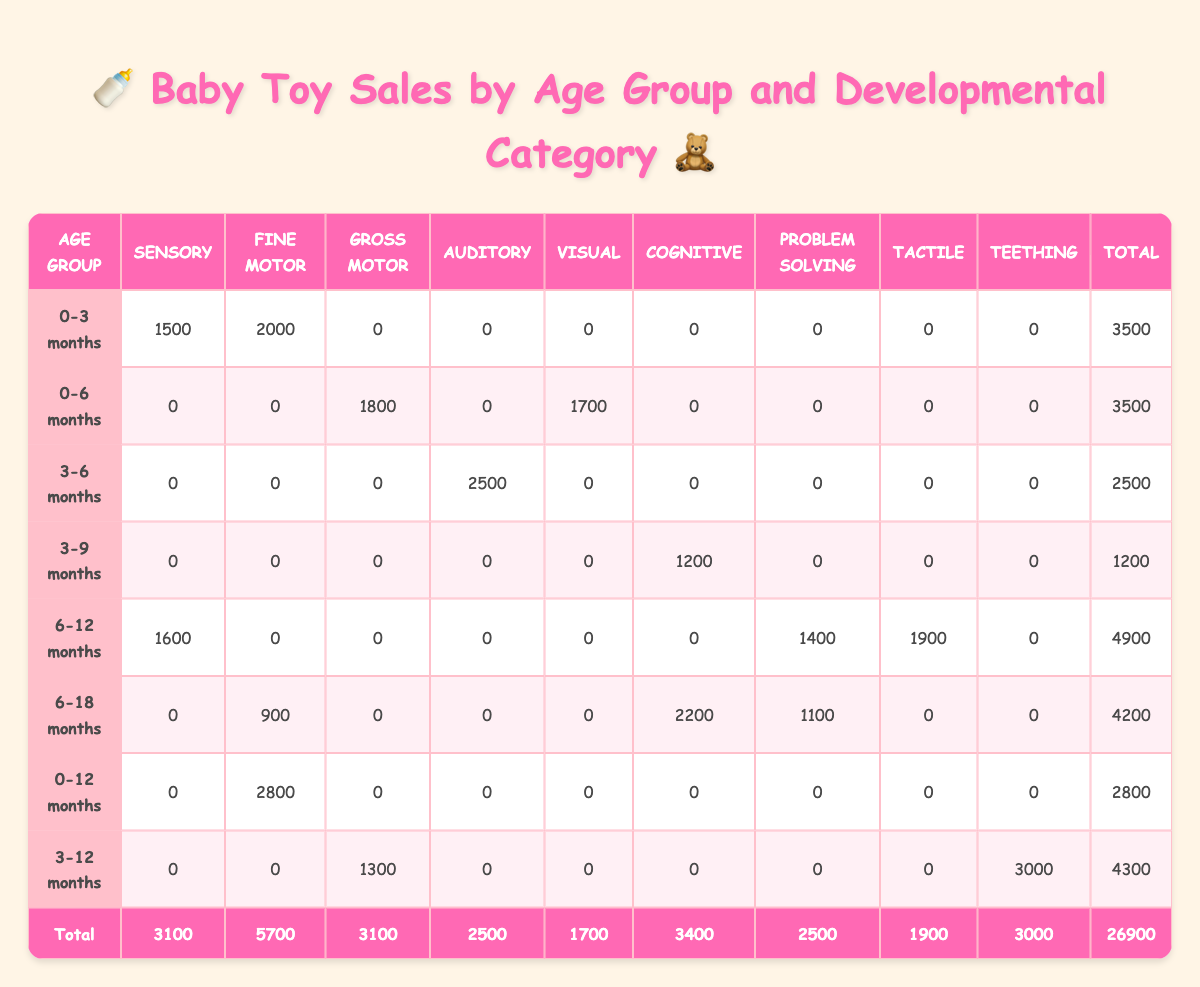What is the total sales quantity for toys designed for the age group 0-3 months? From the table, the sales quantity for the age group 0-3 months is listed as 1500 for Sensory and 2000 for Fine Motor toys. Summing these gives 1500 + 2000 = 3500.
Answer: 3500 Which age group has the highest sales quantity for Auditory toys? Referring to the table, only the age group 3-6 months has sales quantity for Auditory toys, which is 2500. Other age groups do not have any sales for this category, making this the highest.
Answer: 3-6 months Is there any age group that has sales for Teething toys? Checking the table reveals that only the age group 3-12 months has a sales quantity for Teething toys listed as 3000. Therefore, there is one age group with sales for this category.
Answer: Yes What developmental category has the highest total sales across all age groups? By examining the total sales for each category, we see Sensory has 3100, Fine Motor has 5700, Gross Motor has 3100, Auditory has 2500, Visual has 1700, Cognitive has 3400, Problem Solving has 2500, Tactile has 1900, and Teething has 3000. The highest is Fine Motor with 5700.
Answer: Fine Motor What is the average sales quantity for toys in the age group 6-12 months? The sales quantities for the 6-12 months age group are 1600 (Sensory), 0 (Fine Motor), 0 (Gross Motor), 0 (Auditory), 0 (Visual), 0 (Cognitive), 1400 (Problem Solving), 1900 (Tactile), and 0 (Teething), which gives a total of 4900. With 8 entries, the average is 4900 / 8 = 612.5.
Answer: 612.5 Which category has the lowest sales quantity? Looking at the total sales for each category, the lowest figure is for Visual toys at 1700. All other categories have higher totals.
Answer: Visual If we compare the sales of Cognitive toys between the age groups 3-9 months and 6-18 months, which one has a higher quantity? The sales quantity for Cognitive toys is 1200 for the 3-9 months age group and 2200 for the 6-18 months age group. Therefore, 6-18 months has the higher quantity.
Answer: 6-18 months What is the total sales of toys in the age group 3-12 months? The sales quantities for this age group are 1300 (Gross Motor), 0 (Fine Motor), 0 (Auditory), 0 (Visual), 0 (Cognitive), 0 (Problem Solving), 0 (Tactile), and 3000 (Teething), summing them gives 1300 + 3000 = 4300.
Answer: 4300 